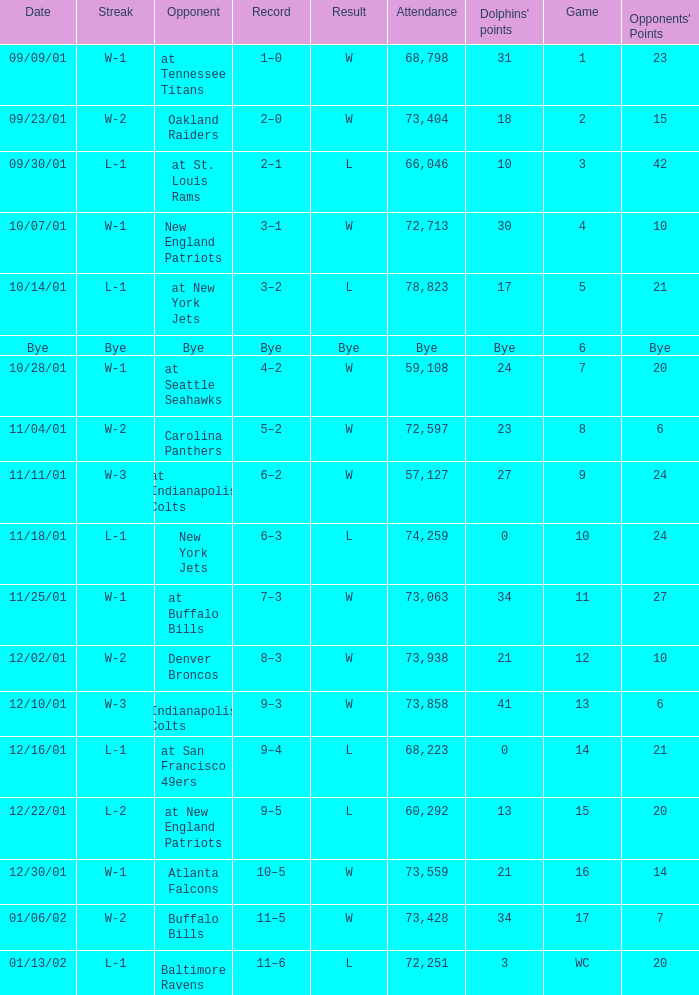What was the attendance of the Oakland Raiders game? 73404.0. 